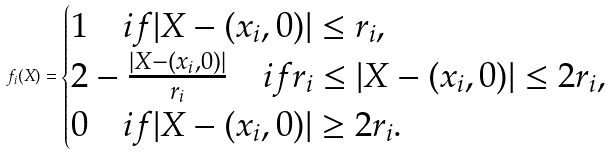Convert formula to latex. <formula><loc_0><loc_0><loc_500><loc_500>f _ { i } ( X ) = \begin{cases} 1 \quad i f | X - ( x _ { i } , 0 ) | \leq r _ { i } , \\ 2 - \frac { | X - ( x _ { i } , 0 ) | } { r _ { i } } \quad i f r _ { i } \leq | X - ( x _ { i } , 0 ) | \leq 2 r _ { i } , \\ 0 \quad i f | X - ( x _ { i } , 0 ) | \geq 2 r _ { i } . \end{cases}</formula> 